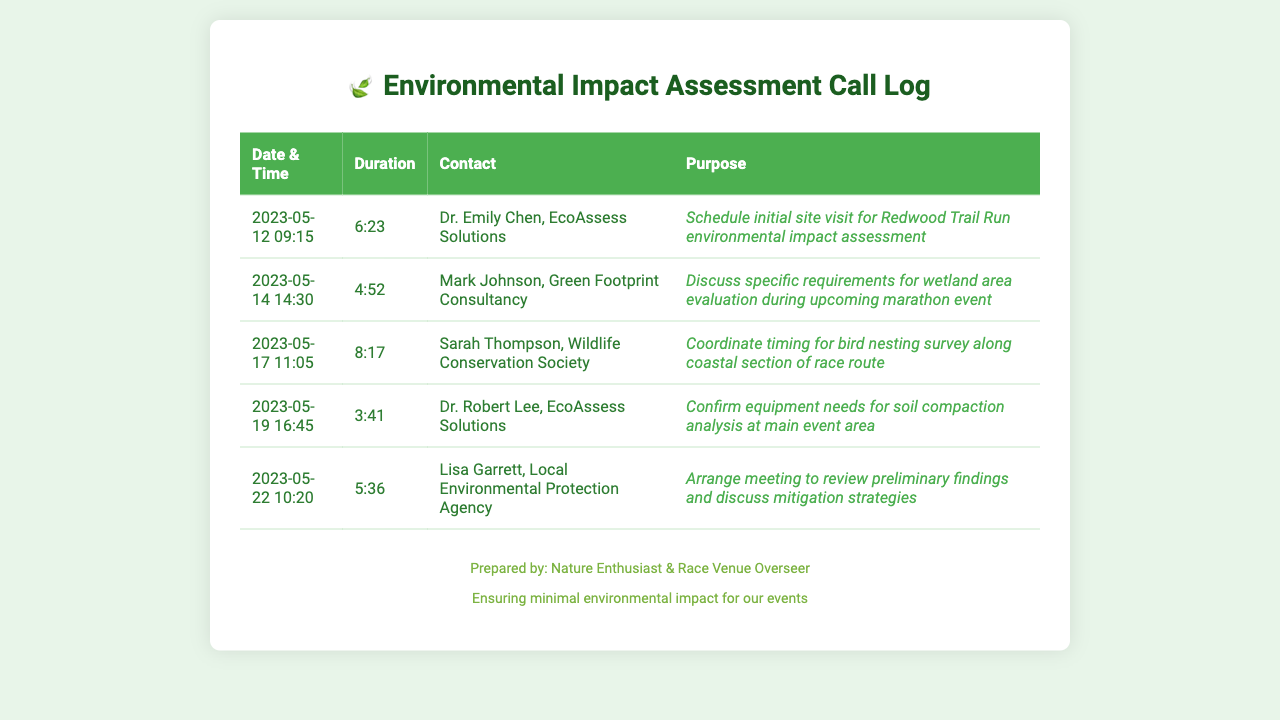what was the purpose of the call on May 12? The purpose is stated in the call log entry, which is to schedule the initial site visit for the Redwood Trail Run environmental impact assessment.
Answer: Schedule initial site visit for Redwood Trail Run environmental impact assessment who was called on May 19? The call log specifies that Dr. Robert Lee from EcoAssess Solutions was contacted on this date.
Answer: Dr. Robert Lee, EcoAssess Solutions how long was the call with Lisa Garrett? The duration of the call with Lisa Garrett is listed directly in the call log, which shows the length of the call as 5:36.
Answer: 5:36 what date was the call to discuss wetland area evaluation? The call regarding the wetland area evaluation took place on May 14, according to the documented schedule.
Answer: May 14 which organization did Sarah Thompson represent? The log indicates that Sarah Thompson was from the Wildlife Conservation Society, detailing her representation during the call.
Answer: Wildlife Conservation Society how many calls were made in total? By counting the entries in the call log, we determine there are 5 calls documented in total.
Answer: 5 what was discussed during the call on May 22? The call log entry provides the purpose, which was to arrange a meeting to review preliminary findings and discuss mitigation strategies.
Answer: Arrange meeting to review preliminary findings and discuss mitigation strategies which contact provided equipment needs confirmation? The call log states that Dr. Robert Lee was the contact who discussed equipment needs for soil compaction analysis.
Answer: Dr. Robert Lee, EcoAssess Solutions 